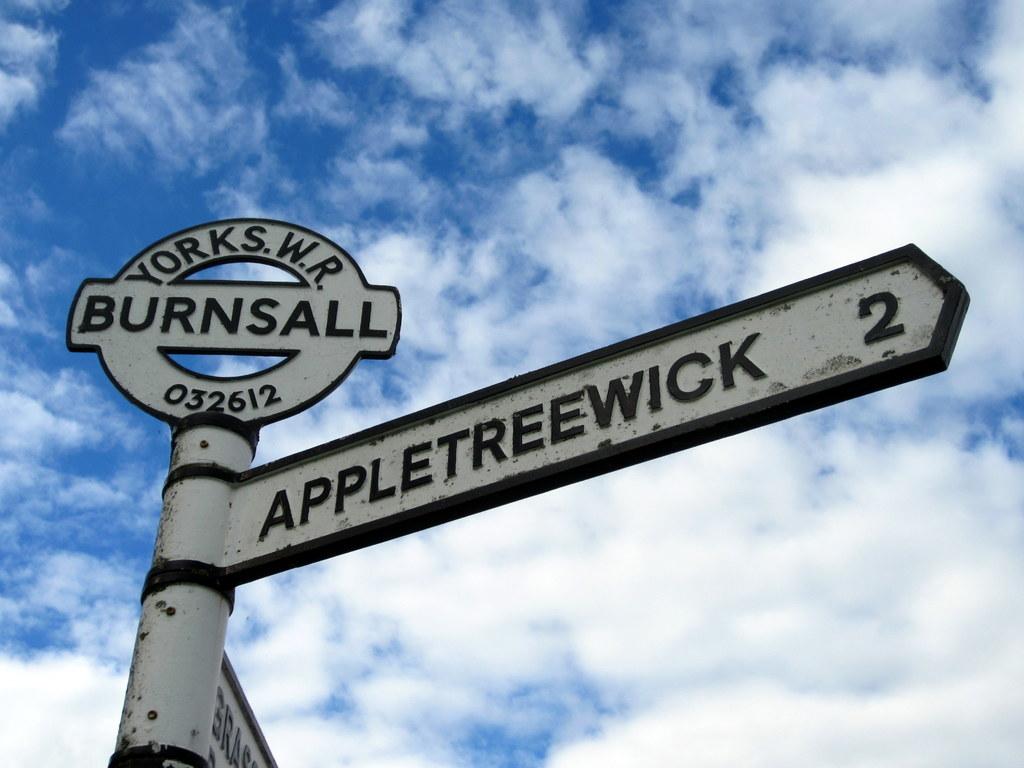Where is 2 km away?
Give a very brief answer. Appletreewick. What is the number near the top of the sign?
Provide a succinct answer. 032612. 